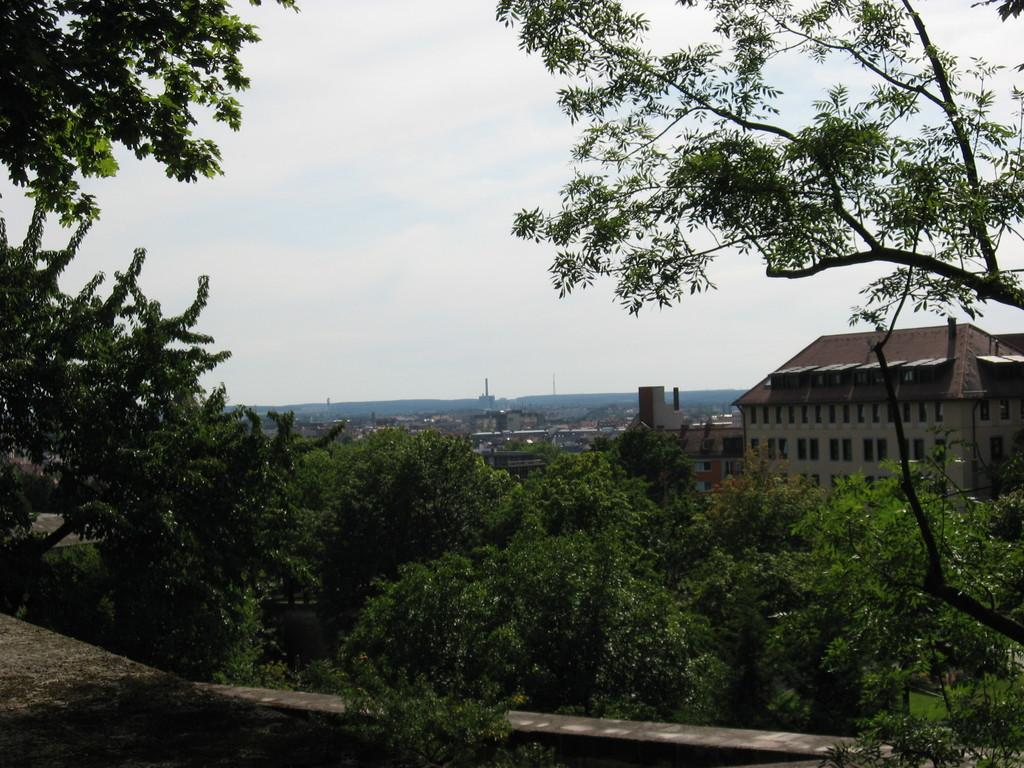What type of natural elements can be seen in the image? There are trees in the image. What type of man-made structures are present in the image? There are buildings in the image. What is at the bottom of the image? There is a wall at the bottom of the image. What is visible at the top of the image? The sky is visible at the top of the image. What letter is written on the wall at the bottom of the image? There is no letter written on the wall at the bottom of the image. What type of cream is being used to paint the trees in the image? There is no cream being used to paint the trees in the image; they are natural trees. 